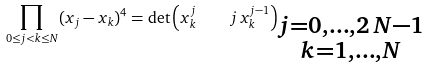<formula> <loc_0><loc_0><loc_500><loc_500>\prod _ { 0 \leq j < k \leq N } ( x _ { j } - x _ { k } ) ^ { 4 } = \det \left ( x _ { k } ^ { j } \quad j \, x _ { k } ^ { j - 1 } \right ) _ { \substack { j = 0 , \dots , 2 \, N - 1 \\ k = 1 , \dots , N } }</formula> 